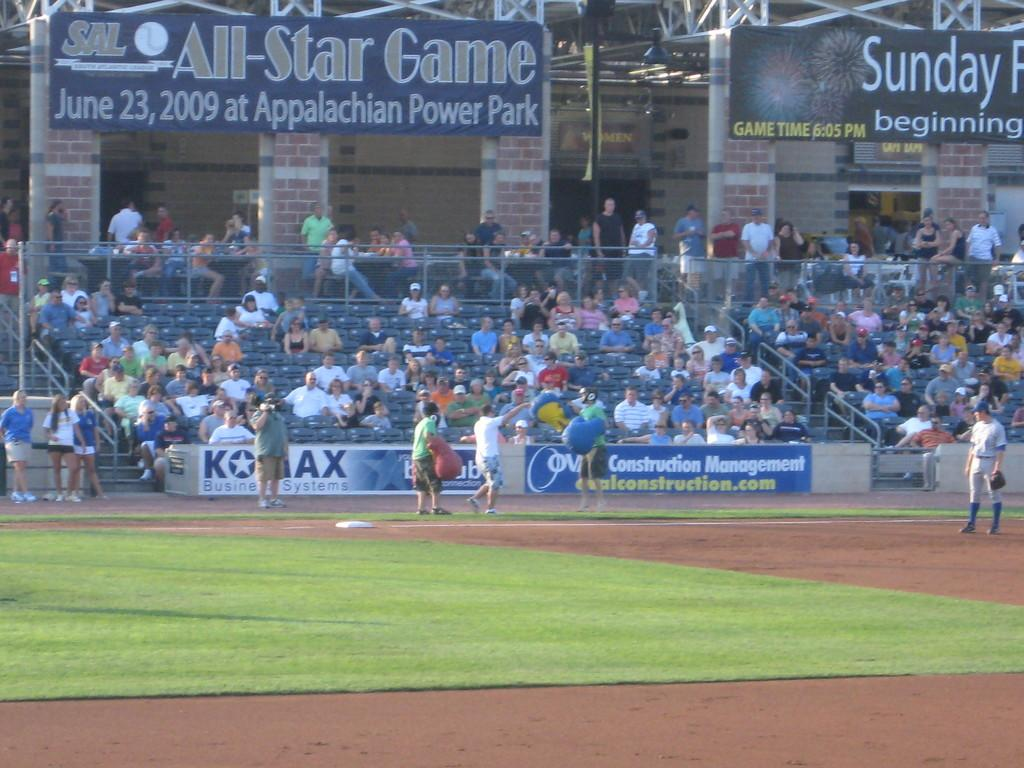<image>
Present a compact description of the photo's key features. A baseball game where a banner advertises an All-Star Game on June 23, 2009 